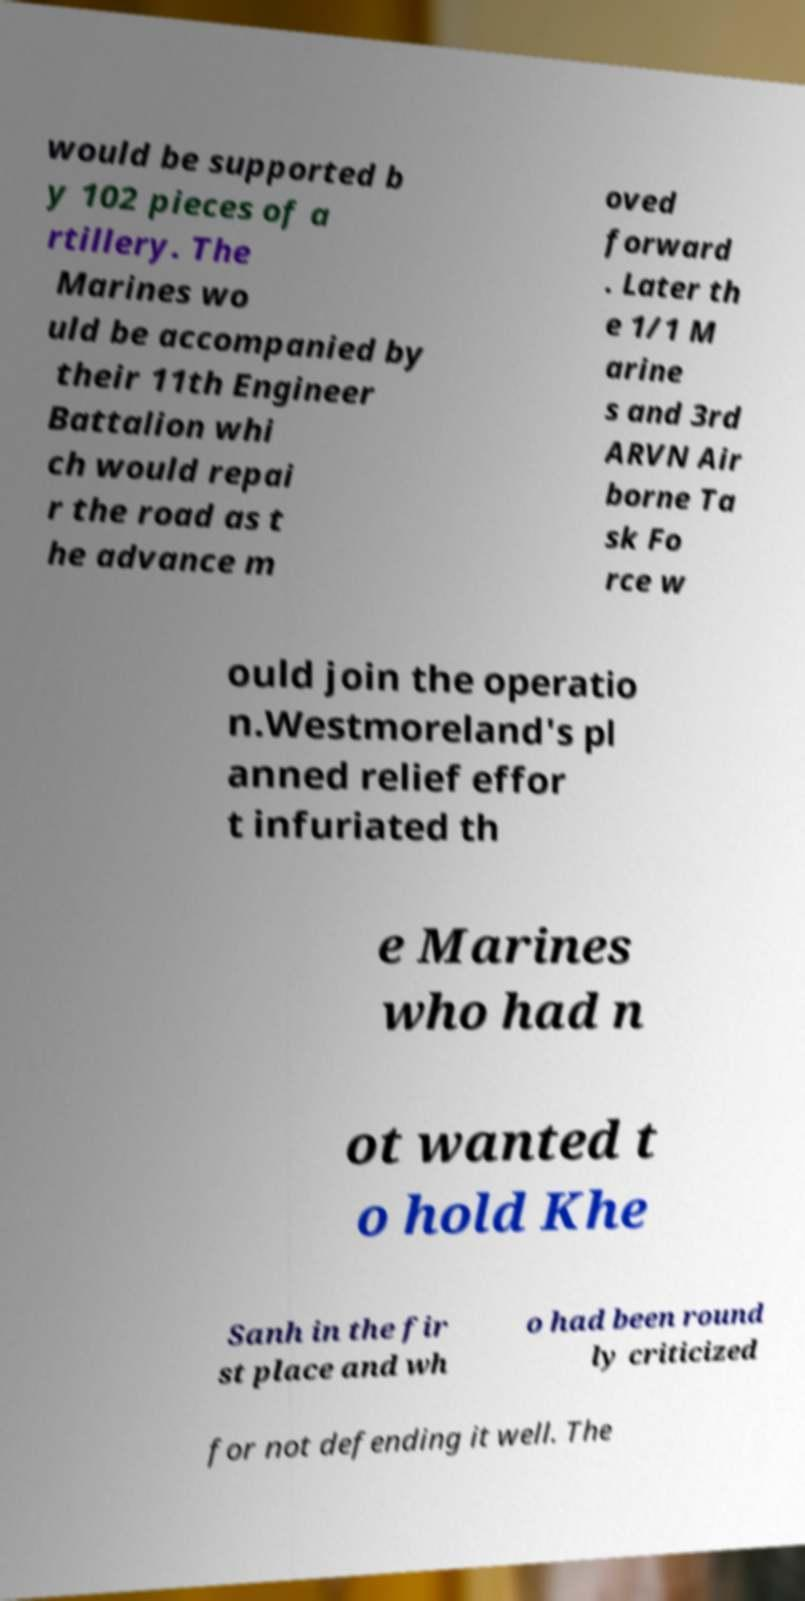Please read and relay the text visible in this image. What does it say? would be supported b y 102 pieces of a rtillery. The Marines wo uld be accompanied by their 11th Engineer Battalion whi ch would repai r the road as t he advance m oved forward . Later th e 1/1 M arine s and 3rd ARVN Air borne Ta sk Fo rce w ould join the operatio n.Westmoreland's pl anned relief effor t infuriated th e Marines who had n ot wanted t o hold Khe Sanh in the fir st place and wh o had been round ly criticized for not defending it well. The 